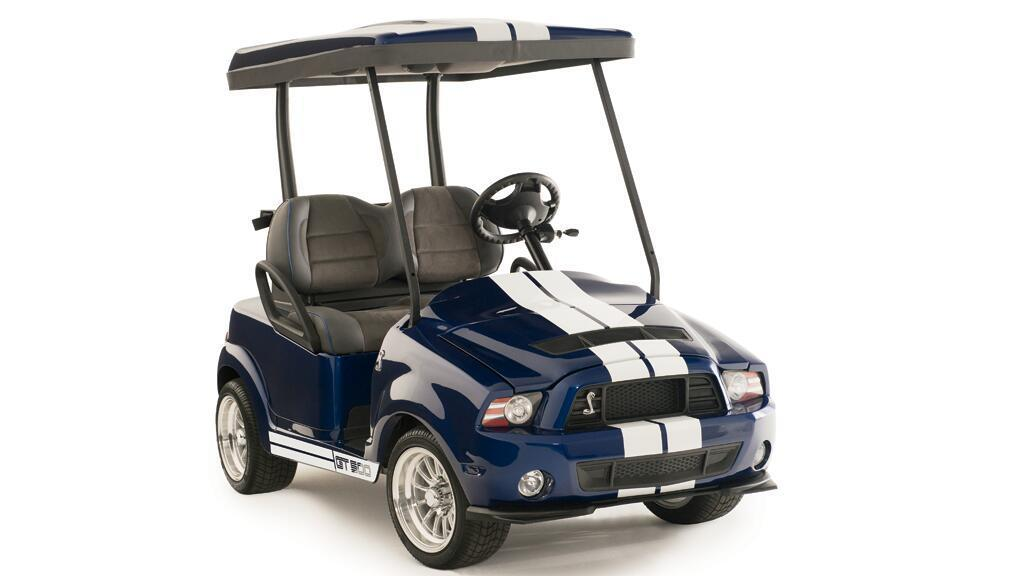What is the main subject of the image? There is a vehicle in the image. What color is the vehicle? The vehicle is dark blue in color. How many seats are in the vehicle? There are two seats in the vehicle. What type of farm animals can be seen in the image? There are no farm animals present in the image; it features a dark blue vehicle with two seats. Is there an umbrella being used as a protest sign in the image? There is no protest or umbrella present in the image; it only shows a dark blue vehicle with two seats. 